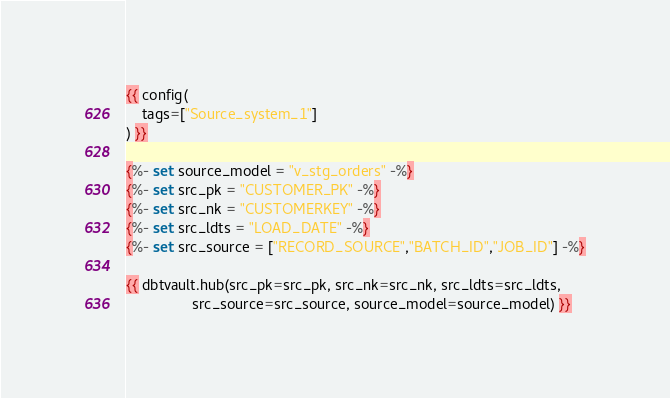<code> <loc_0><loc_0><loc_500><loc_500><_SQL_>{{ config(
    tags=["Source_system_1"]
) }}

{%- set source_model = "v_stg_orders" -%}
{%- set src_pk = "CUSTOMER_PK" -%}
{%- set src_nk = "CUSTOMERKEY" -%}
{%- set src_ldts = "LOAD_DATE" -%}
{%- set src_source = ["RECORD_SOURCE","BATCH_ID","JOB_ID"] -%}

{{ dbtvault.hub(src_pk=src_pk, src_nk=src_nk, src_ldts=src_ldts,
                src_source=src_source, source_model=source_model) }}</code> 